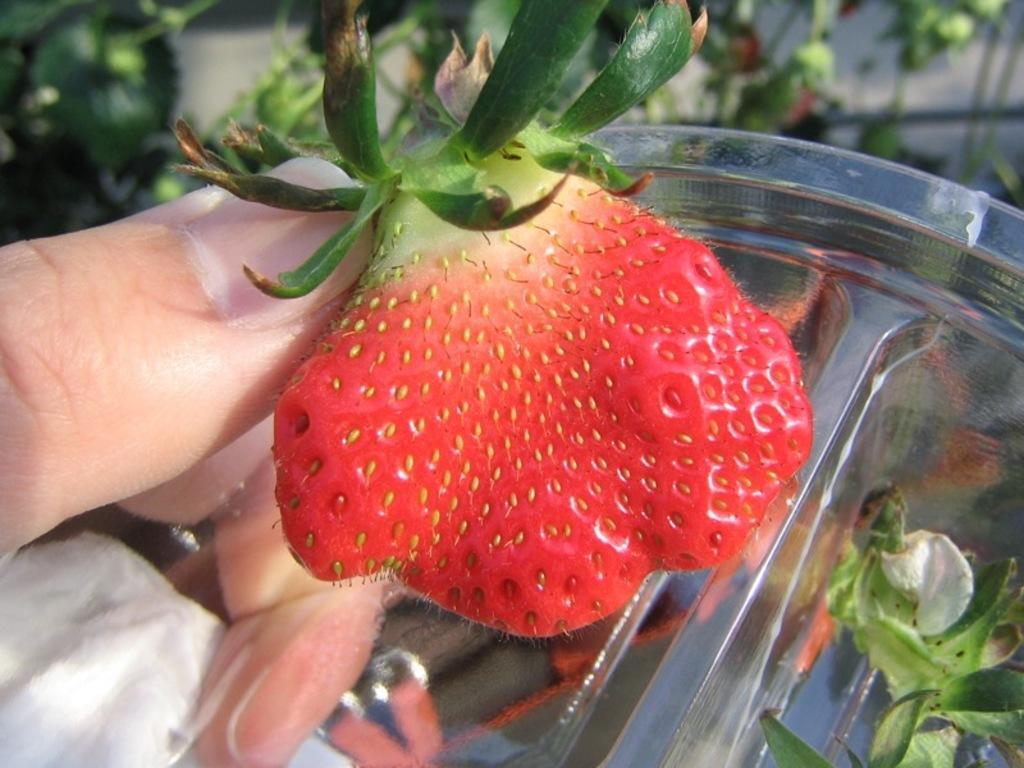Describe this image in one or two sentences. In this image, we can see a fruit. There are fingers on the left side of the image. There is bowl on the right side of the image. 